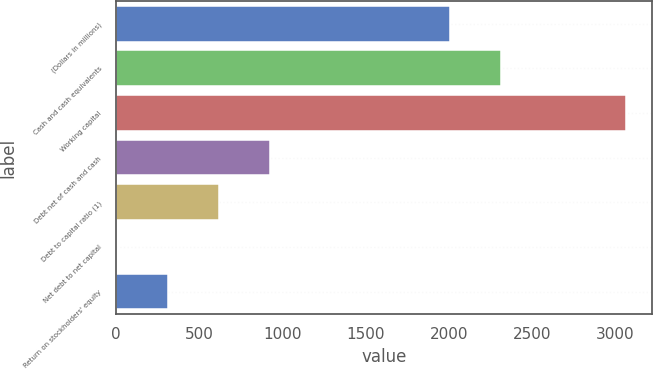Convert chart to OTSL. <chart><loc_0><loc_0><loc_500><loc_500><bar_chart><fcel>(Dollars in millions)<fcel>Cash and cash equivalents<fcel>Working capital<fcel>Debt net of cash and cash<fcel>Debt to capital ratio (1)<fcel>Net debt to net capital<fcel>Return on stockholders' equity<nl><fcel>2009<fcel>2314.89<fcel>3065<fcel>923.77<fcel>617.88<fcel>6.1<fcel>311.99<nl></chart> 